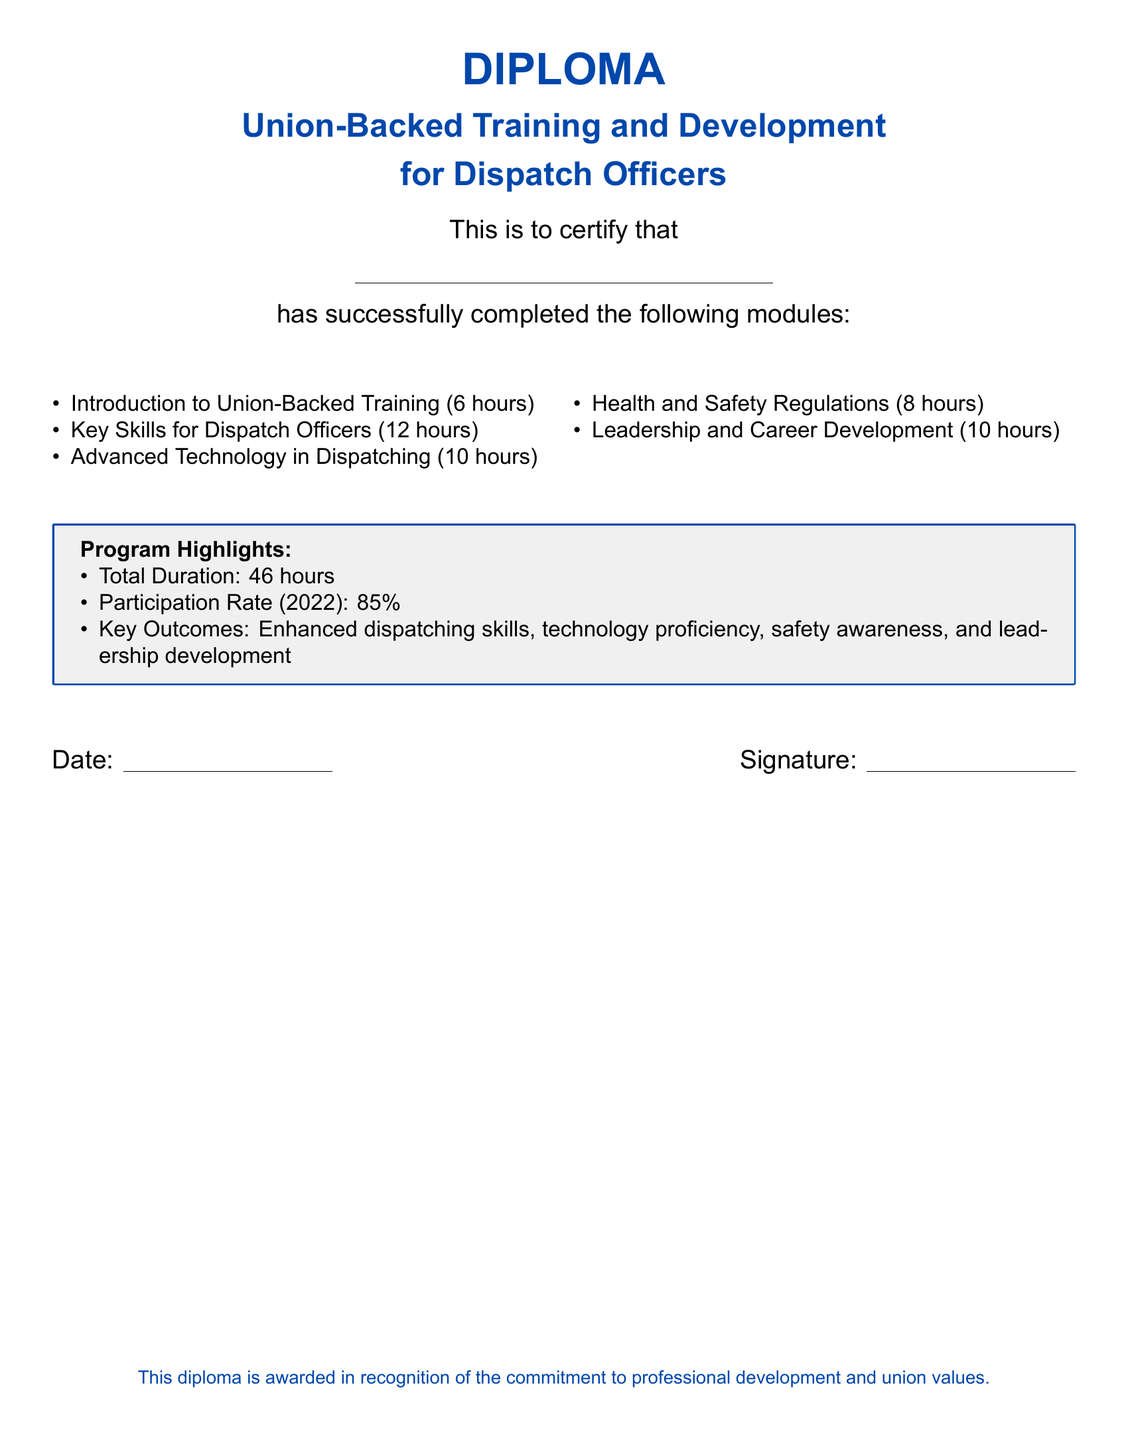What is the title of the diploma? The title of the diploma is prominently displayed at the top of the document, which reads "Union-Backed Training and Development."
Answer: Union-Backed Training and Development How many hours is the "Introduction to Union-Backed Training" module? The document lists the hours for each module, with "Introduction to Union-Backed Training" listed as 6 hours.
Answer: 6 hours What is the participation rate for the training program in 2022? The document provides the participation rate in a highlighted box, indicating an 85% participation rate for 2022.
Answer: 85% What is one of the key outcomes of the training program? The document outlines key outcomes in a highlighted box, mentioning "enhanced dispatching skills" as one of them.
Answer: Enhanced dispatching skills How many total hours does the training program span? The total duration is specified within the program highlights and sums to 46 hours.
Answer: 46 hours Which module has the longest duration? By examining the list of modules, "Key Skills for Dispatch Officers" is noted as the longest at 12 hours.
Answer: Key Skills for Dispatch Officers What key skill area is developed besides health and safety? The program highlights additional outcomes, such as "leadership development," which accompanies health and safety.
Answer: Leadership development Is this diploma awarded in recognition of union values? The final note in the document emphasizes that the diploma is awarded in recognition of "commitment to professional development and union values."
Answer: Yes 